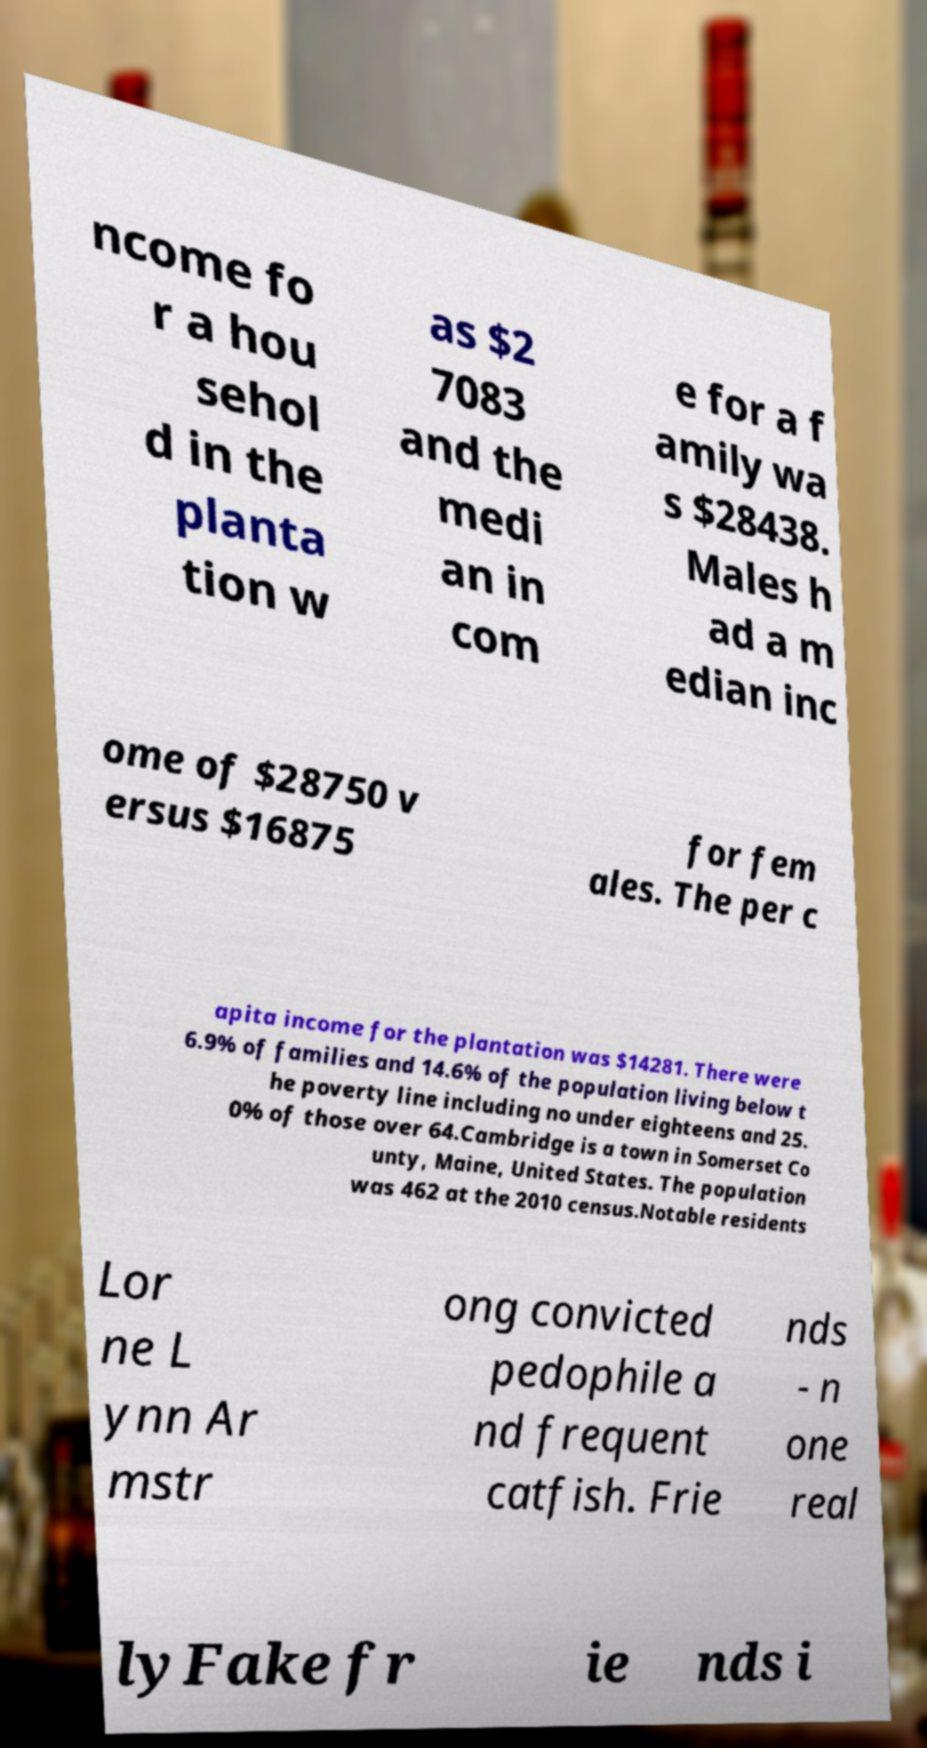Can you accurately transcribe the text from the provided image for me? ncome fo r a hou sehol d in the planta tion w as $2 7083 and the medi an in com e for a f amily wa s $28438. Males h ad a m edian inc ome of $28750 v ersus $16875 for fem ales. The per c apita income for the plantation was $14281. There were 6.9% of families and 14.6% of the population living below t he poverty line including no under eighteens and 25. 0% of those over 64.Cambridge is a town in Somerset Co unty, Maine, United States. The population was 462 at the 2010 census.Notable residents Lor ne L ynn Ar mstr ong convicted pedophile a nd frequent catfish. Frie nds - n one real lyFake fr ie nds i 